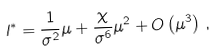<formula> <loc_0><loc_0><loc_500><loc_500>l ^ { * } = \frac { 1 } { \sigma ^ { 2 } } \mu + \frac { \chi } { \sigma ^ { 6 } } \mu ^ { 2 } + O \left ( \mu ^ { 3 } \right ) \, ,</formula> 